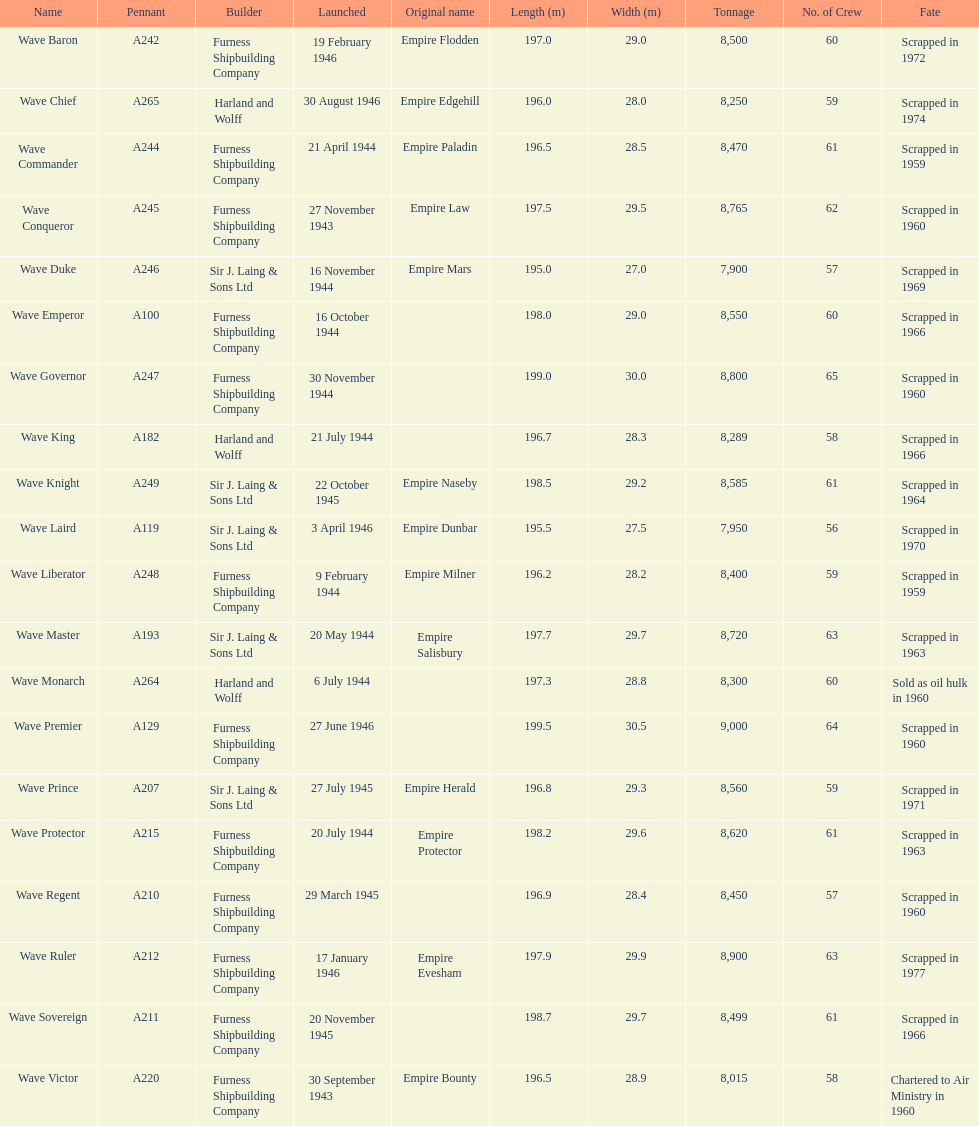How many ships were launched in the year 1944? 9. 